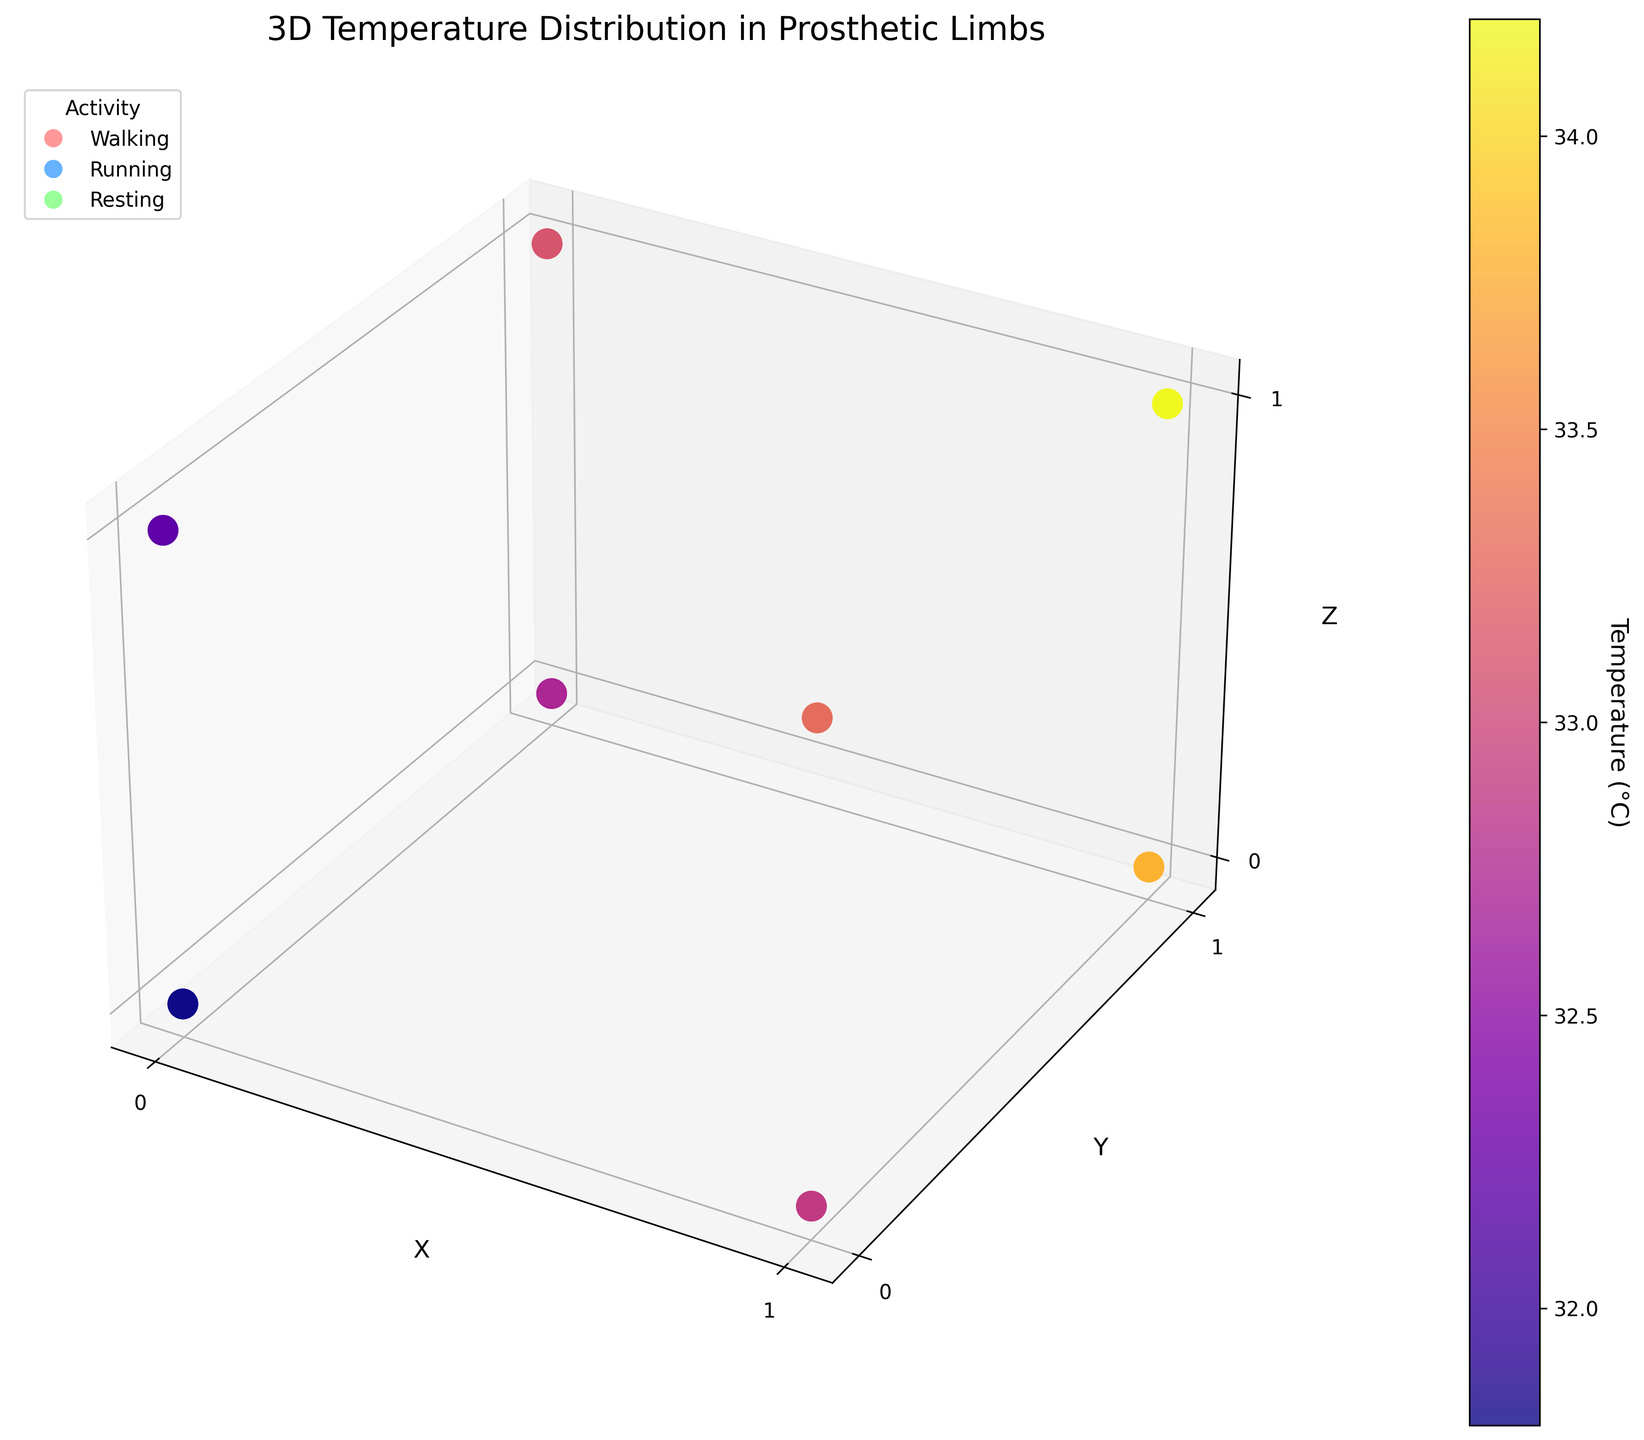How many activities are represented in this figure? The legend in the figure indicates that there are 3 different activities shown.
Answer: 3 What is the highest temperature recorded during the "Walking" activity? The color bar indicates temperature values, and by looking at the data points for "Walking", the highest temperature recorded is 35.7°C.
Answer: 35.7°C Which activity shows the lowest average temperature? To find this, calculate the average temperature for each activity. "Resting" has the lowest temperatures, averaging around 32.5°C.
Answer: Resting How does the temperature distribution in the "Running" activity compare to the "Resting" activity? The "Running" activity shows higher overall temperatures compared to "Resting", with "Running" temperatures reaching up to 37.1°C while "Resting" peaks at 34.2°C.
Answer: Running > Resting What is the range of temperatures observed during the "Walking" activity? The difference between the maximum and minimum temperature values for the "Walking" activity is 35.7°C - 32.5°C = 3.2°C.
Answer: 3.2°C Which activity has the greatest variation in temperature? The variation is determined by the range, and the "Running" activity has the highest range from 33.2°C to 37.1°C, a difference of 3.9°C.
Answer: Running Is the temperature distribution more uniform in any particular activity? By observing the spread and color consistency of the data points, the "Resting" activity appears to have the most uniform temperature distribution.
Answer: Resting On the x-axis at x=1, which activity has the highest temperature? Looking across the x-axis at x=1, the "Running" activity has the highest temperature at 37.1°C.
Answer: Running What is the positional relationship between the highest temperatures in the "Walking" activity? The highest temperatures in the "Walking" activity are recorded at the coordinates (1,1,1).
Answer: (1,1,1) Are there any locations where all activities show similar temperatures? At the coordinate (0,0,0), all activities show temperatures around 32-33°C, indicating similar values in this space.
Answer: Yes 